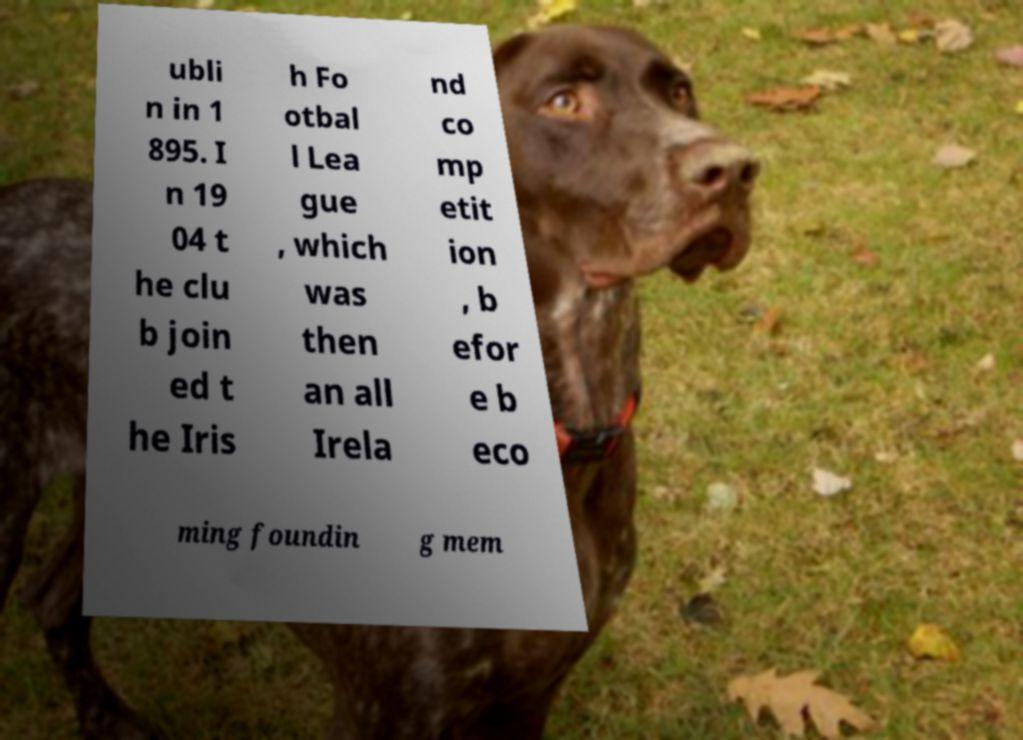Please identify and transcribe the text found in this image. ubli n in 1 895. I n 19 04 t he clu b join ed t he Iris h Fo otbal l Lea gue , which was then an all Irela nd co mp etit ion , b efor e b eco ming foundin g mem 